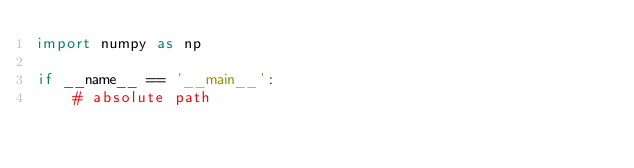<code> <loc_0><loc_0><loc_500><loc_500><_Python_>import numpy as np

if __name__ == '__main__':
    # absolute path</code> 